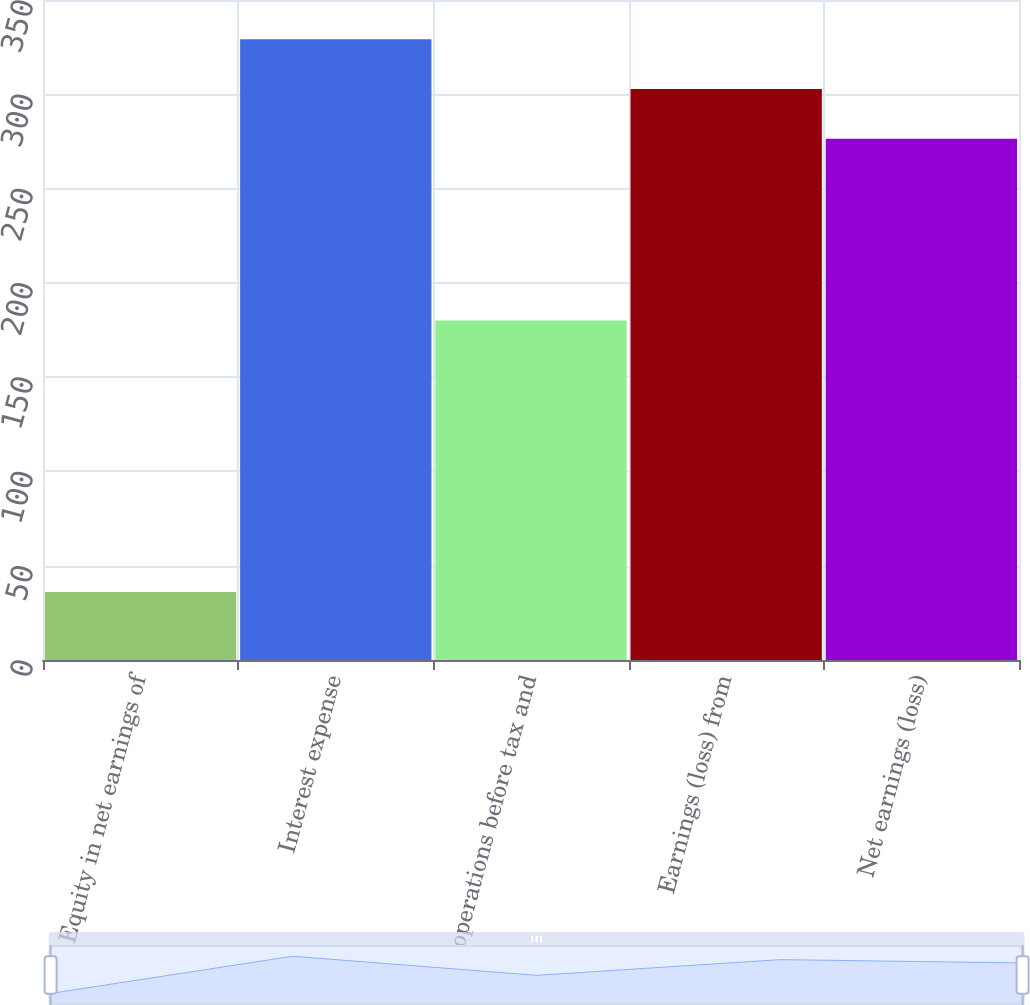Convert chart to OTSL. <chart><loc_0><loc_0><loc_500><loc_500><bar_chart><fcel>Equity in net earnings of<fcel>Interest expense<fcel>operations before tax and<fcel>Earnings (loss) from<fcel>Net earnings (loss)<nl><fcel>36<fcel>329.2<fcel>180<fcel>302.8<fcel>276.4<nl></chart> 